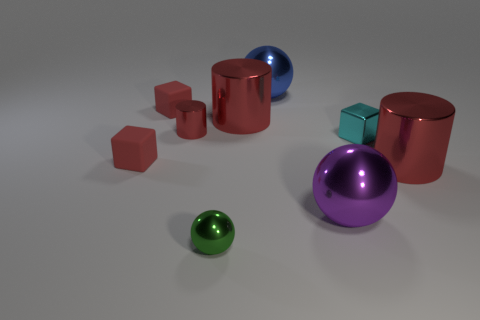There is a object that is in front of the small cyan block and left of the green thing; how big is it?
Ensure brevity in your answer.  Small. What size is the ball behind the red shiny cylinder that is in front of the small shiny cylinder that is to the left of the green shiny object?
Give a very brief answer. Large. What number of other objects are the same color as the small sphere?
Your response must be concise. 0. There is a metallic cylinder that is on the left side of the green metallic sphere; is it the same color as the shiny cube?
Offer a very short reply. No. How many objects are either big blue shiny balls or large red metallic things?
Provide a short and direct response. 3. There is a block that is right of the tiny cylinder; what is its color?
Your answer should be compact. Cyan. Is the number of large blue metal objects behind the blue sphere less than the number of big blue objects?
Offer a very short reply. Yes. Are there any other things that are the same size as the blue shiny object?
Ensure brevity in your answer.  Yes. Does the cyan thing have the same material as the large blue ball?
Give a very brief answer. Yes. What number of things are either large cylinders that are on the right side of the purple object or red cylinders that are on the right side of the large blue shiny thing?
Your response must be concise. 1. 